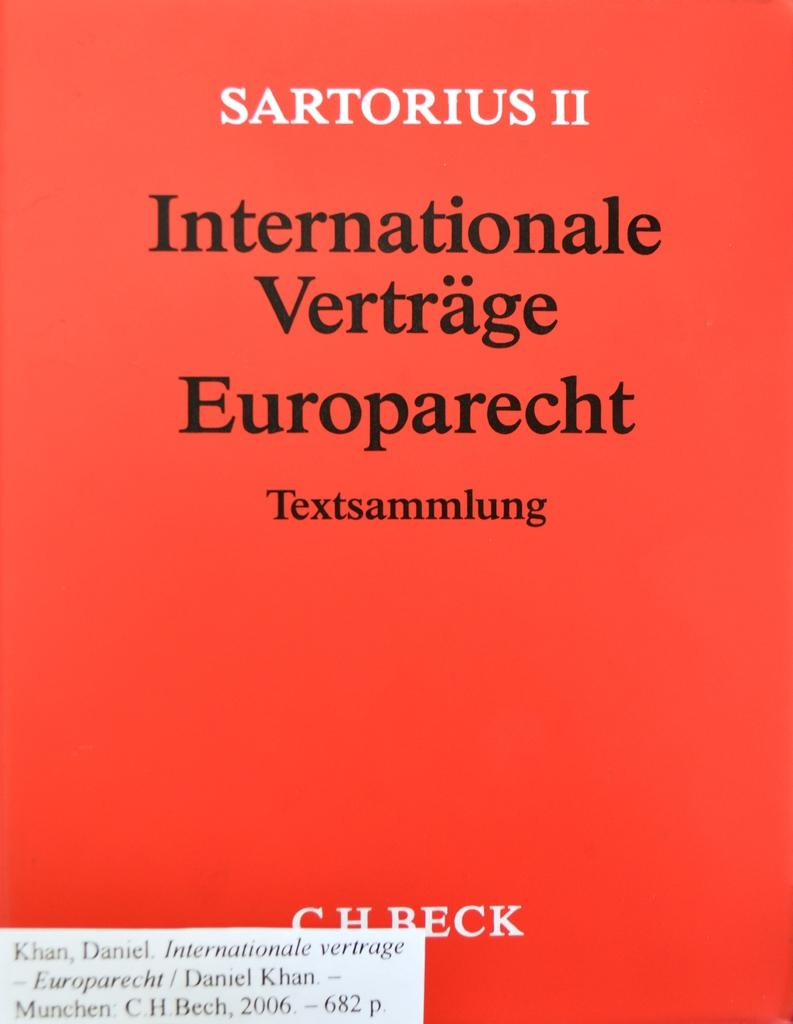<image>
Render a clear and concise summary of the photo. A book cover with a red background and the title "Internationale Vertrage Europarecht" in black letters. 